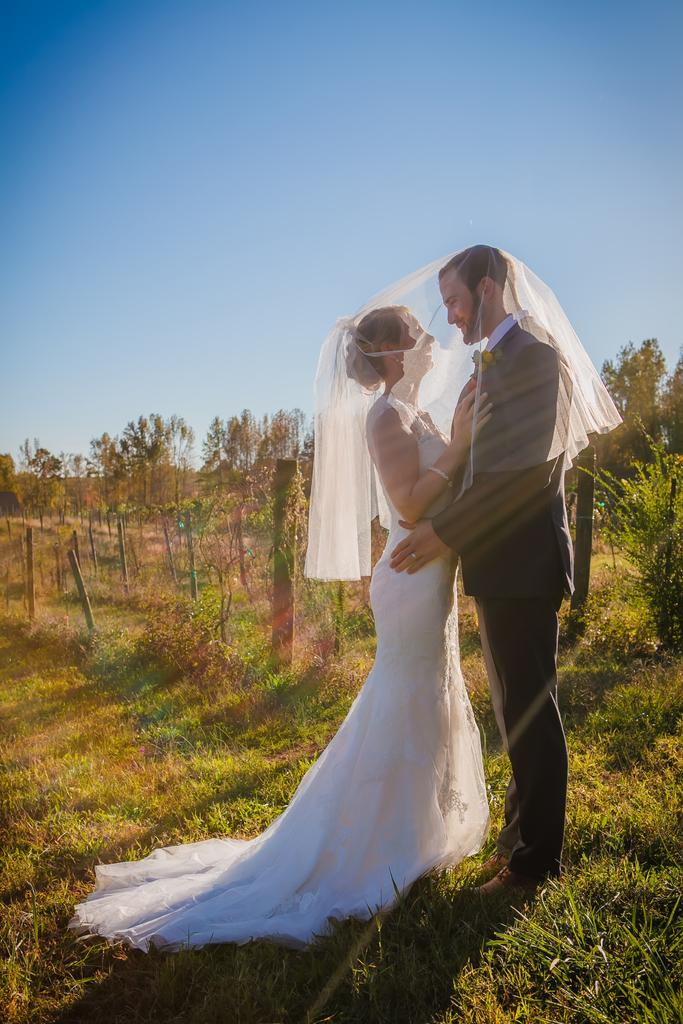Who are the two main subjects in the image? There is a bride and a bridegroom in the image. What type of environment is depicted in the image? The image shows a grassy area with trees and plants. What can be seen in the background of the image? There are poles and the sky visible in the image. What arithmetic problem is the pig solving in the image? There is no pig present in the image, and therefore no arithmetic problem can be observed. 